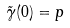Convert formula to latex. <formula><loc_0><loc_0><loc_500><loc_500>\tilde { \gamma } ( 0 ) = p</formula> 